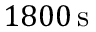<formula> <loc_0><loc_0><loc_500><loc_500>{ 1 8 0 0 } \, s</formula> 